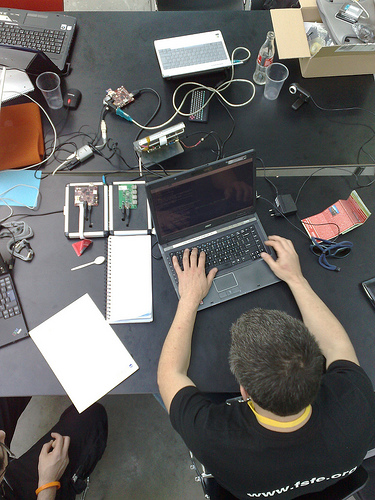<image>
Is there a computer under the soda bottle? No. The computer is not positioned under the soda bottle. The vertical relationship between these objects is different. Where is the man in relation to the laptop? Is it in front of the laptop? Yes. The man is positioned in front of the laptop, appearing closer to the camera viewpoint. 